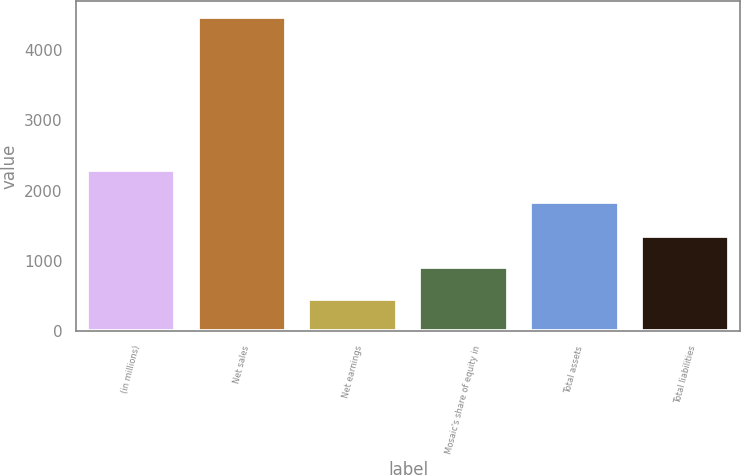Convert chart to OTSL. <chart><loc_0><loc_0><loc_500><loc_500><bar_chart><fcel>(in millions)<fcel>Net sales<fcel>Net earnings<fcel>Mosaic's share of equity in<fcel>Total assets<fcel>Total liabilities<nl><fcel>2287.09<fcel>4475.2<fcel>463.99<fcel>909.68<fcel>1841.4<fcel>1355.37<nl></chart> 